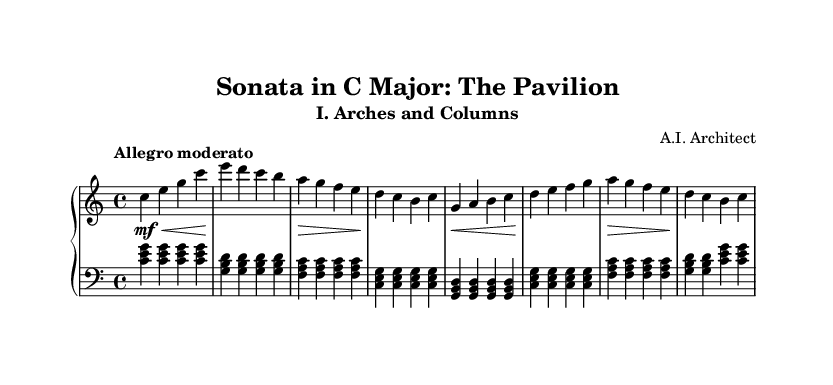What is the key signature of this music? The key signature displayed at the beginning of the score indicates that the music is in C major, which has no sharps or flats.
Answer: C major What is the time signature of this piece? The time signature shown at the beginning of the piece is 4/4, which indicates four beats per measure.
Answer: 4/4 What is the tempo marking of this movement? The tempo marking is written as "Allegro moderato," indicating a moderately fast pace.
Answer: Allegro moderato How many measures are in the right-hand part? By counting the distinct groupings of notes in the right-hand staff, we find that there are 8 complete measures.
Answer: 8 What is the dynamic indication for the first measure? The first measure has a dynamic marking of "mf" (mezzo forte), which signifies a moderately loud volume.
Answer: mf What are the first three notes of the left-hand part? The left-hand part begins with the notes C, E, and G, played as a chord in the first measure.
Answer: C, E, G What type of musical form does this sonata adhere to? The sonata likely follows the classical sonata form, characterized by thematic development and contrasts, typically seen in classical piano sonatas.
Answer: Sonata form 